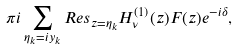<formula> <loc_0><loc_0><loc_500><loc_500>\pi i \sum _ { \eta _ { k } = i y _ { k } } { R e s } _ { z = \eta _ { k } } H _ { \nu } ^ { ( 1 ) } ( z ) F ( z ) e ^ { - i \delta } ,</formula> 